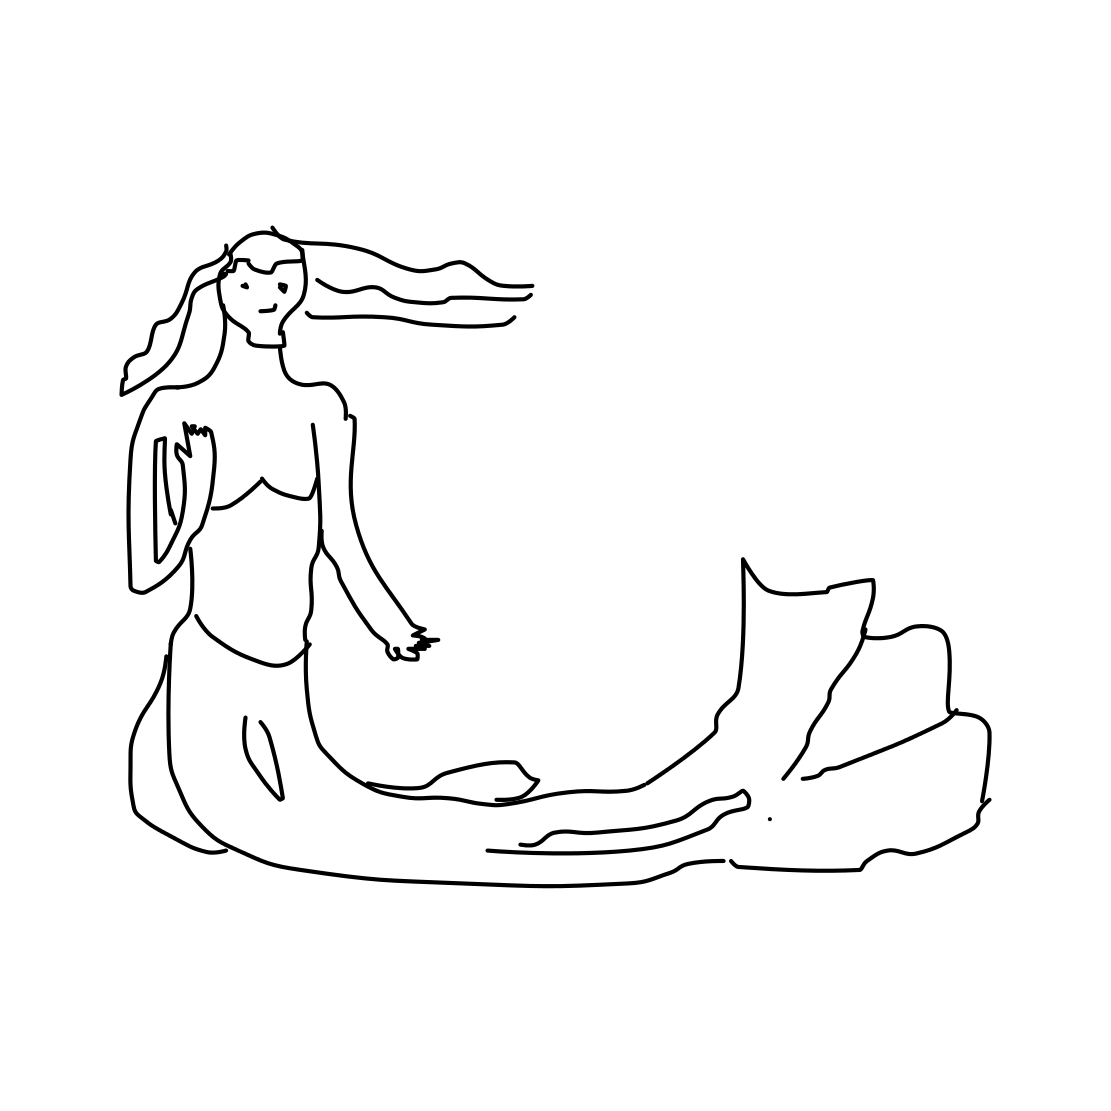In the scene, is a flashlight in it? No 